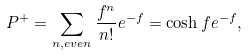Convert formula to latex. <formula><loc_0><loc_0><loc_500><loc_500>P ^ { + } = \sum _ { n , e v e n } \frac { f ^ { n } } { n ! } e ^ { - f } = \cosh f e ^ { - f } ,</formula> 